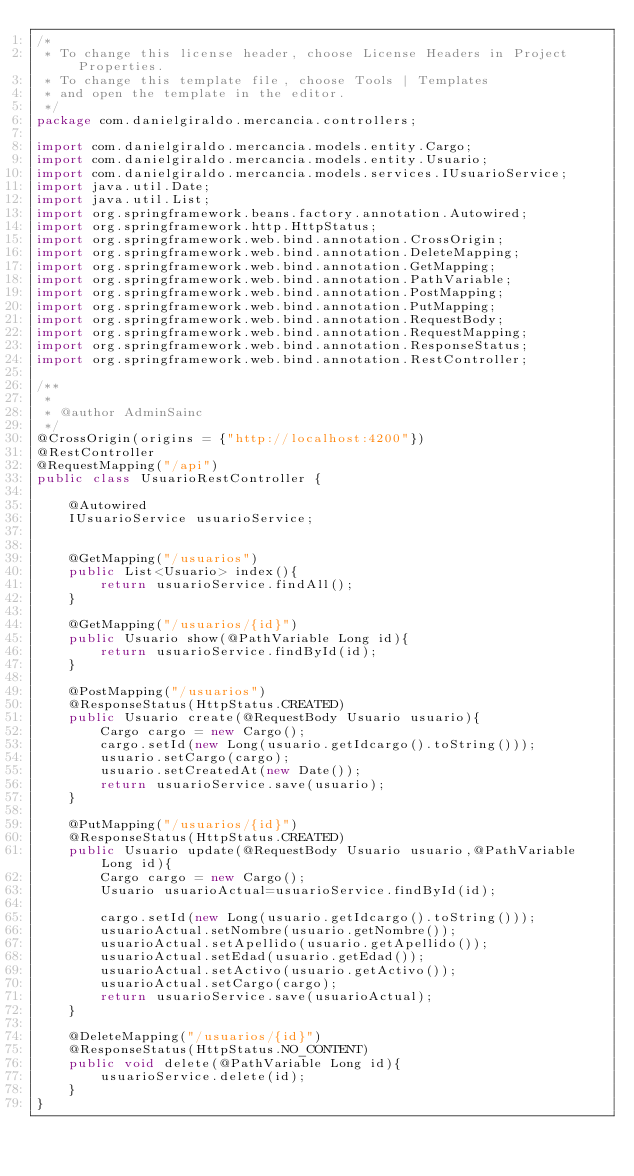<code> <loc_0><loc_0><loc_500><loc_500><_Java_>/*
 * To change this license header, choose License Headers in Project Properties.
 * To change this template file, choose Tools | Templates
 * and open the template in the editor.
 */
package com.danielgiraldo.mercancia.controllers;

import com.danielgiraldo.mercancia.models.entity.Cargo;
import com.danielgiraldo.mercancia.models.entity.Usuario;
import com.danielgiraldo.mercancia.models.services.IUsuarioService;
import java.util.Date;
import java.util.List;
import org.springframework.beans.factory.annotation.Autowired;
import org.springframework.http.HttpStatus;
import org.springframework.web.bind.annotation.CrossOrigin;
import org.springframework.web.bind.annotation.DeleteMapping;
import org.springframework.web.bind.annotation.GetMapping;
import org.springframework.web.bind.annotation.PathVariable;
import org.springframework.web.bind.annotation.PostMapping;
import org.springframework.web.bind.annotation.PutMapping;
import org.springframework.web.bind.annotation.RequestBody;
import org.springframework.web.bind.annotation.RequestMapping;
import org.springframework.web.bind.annotation.ResponseStatus;
import org.springframework.web.bind.annotation.RestController;

/**
 *
 * @author AdminSainc
 */
@CrossOrigin(origins = {"http://localhost:4200"})
@RestController
@RequestMapping("/api")
public class UsuarioRestController {
    
    @Autowired
    IUsuarioService usuarioService;
    
    
    @GetMapping("/usuarios")
    public List<Usuario> index(){
        return usuarioService.findAll();
    }
    
    @GetMapping("/usuarios/{id}")
    public Usuario show(@PathVariable Long id){
        return usuarioService.findById(id);
    }
    
    @PostMapping("/usuarios")
    @ResponseStatus(HttpStatus.CREATED)
    public Usuario create(@RequestBody Usuario usuario){
        Cargo cargo = new Cargo();
        cargo.setId(new Long(usuario.getIdcargo().toString()));
        usuario.setCargo(cargo);
        usuario.setCreatedAt(new Date());
        return usuarioService.save(usuario);
    }
    
    @PutMapping("/usuarios/{id}")
    @ResponseStatus(HttpStatus.CREATED)
    public Usuario update(@RequestBody Usuario usuario,@PathVariable Long id){
        Cargo cargo = new Cargo();
        Usuario usuarioActual=usuarioService.findById(id);
        
        cargo.setId(new Long(usuario.getIdcargo().toString()));
        usuarioActual.setNombre(usuario.getNombre());
        usuarioActual.setApellido(usuario.getApellido());
        usuarioActual.setEdad(usuario.getEdad());
        usuarioActual.setActivo(usuario.getActivo());
        usuarioActual.setCargo(cargo);
        return usuarioService.save(usuarioActual);
    }
    
    @DeleteMapping("/usuarios/{id}")
    @ResponseStatus(HttpStatus.NO_CONTENT)
    public void delete(@PathVariable Long id){
        usuarioService.delete(id);
    }
}
</code> 